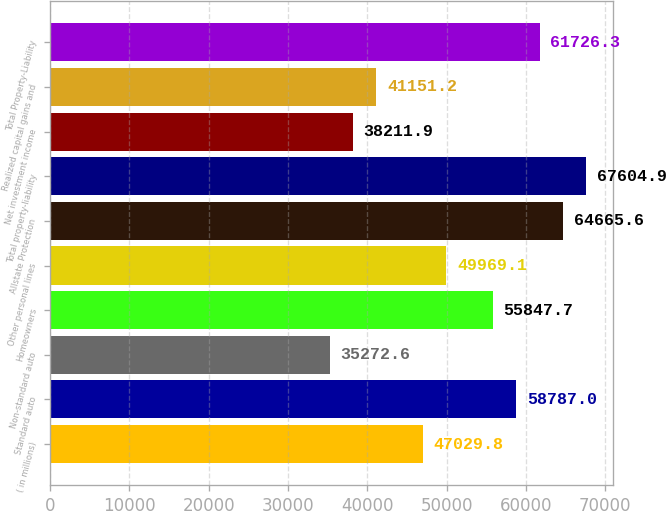Convert chart. <chart><loc_0><loc_0><loc_500><loc_500><bar_chart><fcel>( in millions)<fcel>Standard auto<fcel>Non-standard auto<fcel>Homeowners<fcel>Other personal lines<fcel>Allstate Protection<fcel>Total property-liability<fcel>Net investment income<fcel>Realized capital gains and<fcel>Total Property-Liability<nl><fcel>47029.8<fcel>58787<fcel>35272.6<fcel>55847.7<fcel>49969.1<fcel>64665.6<fcel>67604.9<fcel>38211.9<fcel>41151.2<fcel>61726.3<nl></chart> 